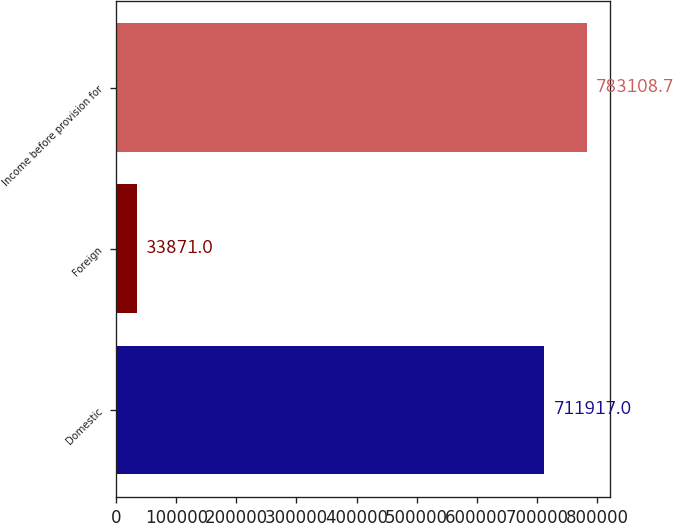Convert chart to OTSL. <chart><loc_0><loc_0><loc_500><loc_500><bar_chart><fcel>Domestic<fcel>Foreign<fcel>Income before provision for<nl><fcel>711917<fcel>33871<fcel>783109<nl></chart> 